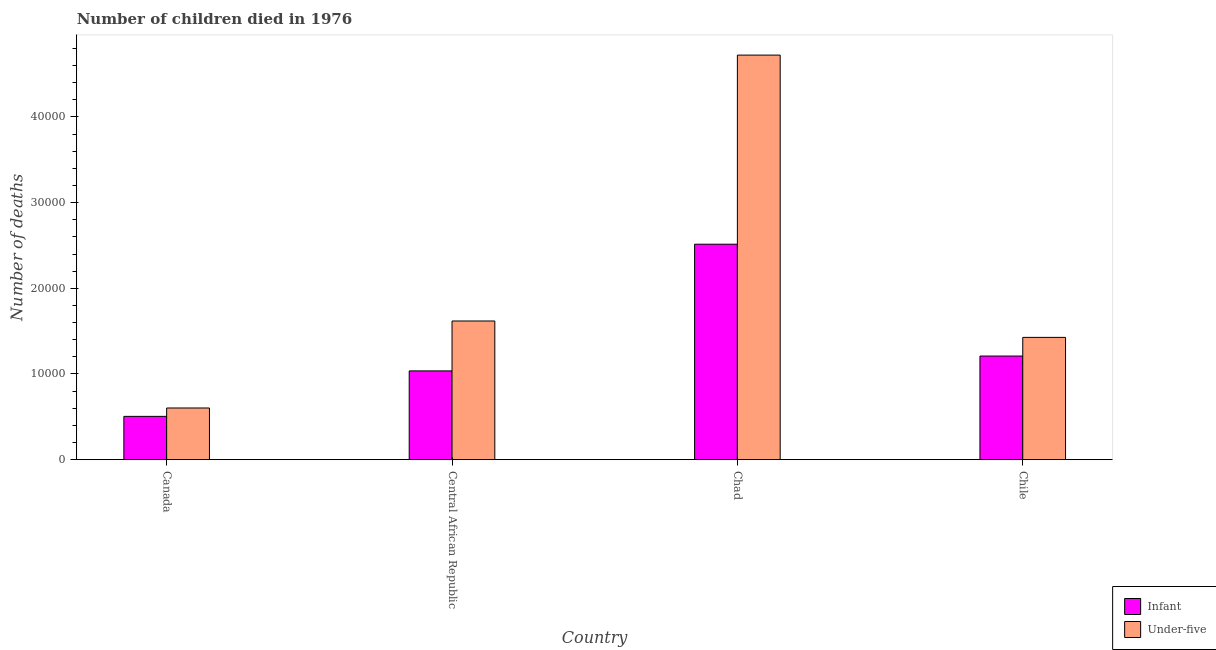How many bars are there on the 1st tick from the left?
Your answer should be compact. 2. How many bars are there on the 4th tick from the right?
Provide a short and direct response. 2. What is the label of the 2nd group of bars from the left?
Ensure brevity in your answer.  Central African Republic. What is the number of infant deaths in Chad?
Provide a succinct answer. 2.51e+04. Across all countries, what is the maximum number of infant deaths?
Offer a very short reply. 2.51e+04. Across all countries, what is the minimum number of under-five deaths?
Give a very brief answer. 6034. In which country was the number of under-five deaths maximum?
Offer a very short reply. Chad. In which country was the number of infant deaths minimum?
Offer a very short reply. Canada. What is the total number of infant deaths in the graph?
Offer a terse response. 5.27e+04. What is the difference between the number of infant deaths in Chad and that in Chile?
Ensure brevity in your answer.  1.30e+04. What is the difference between the number of under-five deaths in Chad and the number of infant deaths in Central African Republic?
Your answer should be very brief. 3.68e+04. What is the average number of infant deaths per country?
Offer a very short reply. 1.32e+04. What is the difference between the number of infant deaths and number of under-five deaths in Chad?
Offer a very short reply. -2.21e+04. In how many countries, is the number of under-five deaths greater than 38000 ?
Provide a short and direct response. 1. What is the ratio of the number of under-five deaths in Canada to that in Central African Republic?
Offer a very short reply. 0.37. What is the difference between the highest and the second highest number of infant deaths?
Make the answer very short. 1.30e+04. What is the difference between the highest and the lowest number of under-five deaths?
Your answer should be very brief. 4.12e+04. In how many countries, is the number of under-five deaths greater than the average number of under-five deaths taken over all countries?
Your answer should be compact. 1. What does the 2nd bar from the left in Central African Republic represents?
Offer a very short reply. Under-five. What does the 2nd bar from the right in Chile represents?
Ensure brevity in your answer.  Infant. Where does the legend appear in the graph?
Provide a succinct answer. Bottom right. How many legend labels are there?
Your answer should be very brief. 2. How are the legend labels stacked?
Make the answer very short. Vertical. What is the title of the graph?
Your response must be concise. Number of children died in 1976. What is the label or title of the Y-axis?
Your answer should be very brief. Number of deaths. What is the Number of deaths of Infant in Canada?
Keep it short and to the point. 5057. What is the Number of deaths of Under-five in Canada?
Offer a terse response. 6034. What is the Number of deaths of Infant in Central African Republic?
Keep it short and to the point. 1.04e+04. What is the Number of deaths of Under-five in Central African Republic?
Make the answer very short. 1.62e+04. What is the Number of deaths in Infant in Chad?
Give a very brief answer. 2.51e+04. What is the Number of deaths of Under-five in Chad?
Provide a short and direct response. 4.72e+04. What is the Number of deaths of Infant in Chile?
Provide a succinct answer. 1.21e+04. What is the Number of deaths of Under-five in Chile?
Your response must be concise. 1.43e+04. Across all countries, what is the maximum Number of deaths in Infant?
Make the answer very short. 2.51e+04. Across all countries, what is the maximum Number of deaths in Under-five?
Offer a very short reply. 4.72e+04. Across all countries, what is the minimum Number of deaths in Infant?
Offer a very short reply. 5057. Across all countries, what is the minimum Number of deaths in Under-five?
Give a very brief answer. 6034. What is the total Number of deaths of Infant in the graph?
Your response must be concise. 5.27e+04. What is the total Number of deaths of Under-five in the graph?
Your answer should be very brief. 8.37e+04. What is the difference between the Number of deaths of Infant in Canada and that in Central African Republic?
Offer a terse response. -5304. What is the difference between the Number of deaths in Under-five in Canada and that in Central African Republic?
Your response must be concise. -1.02e+04. What is the difference between the Number of deaths of Infant in Canada and that in Chad?
Make the answer very short. -2.01e+04. What is the difference between the Number of deaths of Under-five in Canada and that in Chad?
Your answer should be compact. -4.12e+04. What is the difference between the Number of deaths of Infant in Canada and that in Chile?
Your response must be concise. -7039. What is the difference between the Number of deaths in Under-five in Canada and that in Chile?
Your answer should be compact. -8238. What is the difference between the Number of deaths of Infant in Central African Republic and that in Chad?
Provide a succinct answer. -1.48e+04. What is the difference between the Number of deaths of Under-five in Central African Republic and that in Chad?
Give a very brief answer. -3.10e+04. What is the difference between the Number of deaths of Infant in Central African Republic and that in Chile?
Offer a terse response. -1735. What is the difference between the Number of deaths in Under-five in Central African Republic and that in Chile?
Offer a terse response. 1914. What is the difference between the Number of deaths in Infant in Chad and that in Chile?
Make the answer very short. 1.30e+04. What is the difference between the Number of deaths of Under-five in Chad and that in Chile?
Your answer should be very brief. 3.29e+04. What is the difference between the Number of deaths of Infant in Canada and the Number of deaths of Under-five in Central African Republic?
Your answer should be compact. -1.11e+04. What is the difference between the Number of deaths of Infant in Canada and the Number of deaths of Under-five in Chad?
Provide a short and direct response. -4.22e+04. What is the difference between the Number of deaths in Infant in Canada and the Number of deaths in Under-five in Chile?
Offer a very short reply. -9215. What is the difference between the Number of deaths of Infant in Central African Republic and the Number of deaths of Under-five in Chad?
Keep it short and to the point. -3.68e+04. What is the difference between the Number of deaths of Infant in Central African Republic and the Number of deaths of Under-five in Chile?
Your response must be concise. -3911. What is the difference between the Number of deaths in Infant in Chad and the Number of deaths in Under-five in Chile?
Make the answer very short. 1.09e+04. What is the average Number of deaths in Infant per country?
Keep it short and to the point. 1.32e+04. What is the average Number of deaths in Under-five per country?
Keep it short and to the point. 2.09e+04. What is the difference between the Number of deaths in Infant and Number of deaths in Under-five in Canada?
Your answer should be very brief. -977. What is the difference between the Number of deaths of Infant and Number of deaths of Under-five in Central African Republic?
Ensure brevity in your answer.  -5825. What is the difference between the Number of deaths of Infant and Number of deaths of Under-five in Chad?
Offer a terse response. -2.21e+04. What is the difference between the Number of deaths of Infant and Number of deaths of Under-five in Chile?
Ensure brevity in your answer.  -2176. What is the ratio of the Number of deaths in Infant in Canada to that in Central African Republic?
Offer a very short reply. 0.49. What is the ratio of the Number of deaths in Under-five in Canada to that in Central African Republic?
Offer a terse response. 0.37. What is the ratio of the Number of deaths of Infant in Canada to that in Chad?
Offer a very short reply. 0.2. What is the ratio of the Number of deaths in Under-five in Canada to that in Chad?
Your response must be concise. 0.13. What is the ratio of the Number of deaths in Infant in Canada to that in Chile?
Your response must be concise. 0.42. What is the ratio of the Number of deaths of Under-five in Canada to that in Chile?
Give a very brief answer. 0.42. What is the ratio of the Number of deaths in Infant in Central African Republic to that in Chad?
Your answer should be compact. 0.41. What is the ratio of the Number of deaths in Under-five in Central African Republic to that in Chad?
Make the answer very short. 0.34. What is the ratio of the Number of deaths of Infant in Central African Republic to that in Chile?
Offer a terse response. 0.86. What is the ratio of the Number of deaths of Under-five in Central African Republic to that in Chile?
Make the answer very short. 1.13. What is the ratio of the Number of deaths in Infant in Chad to that in Chile?
Keep it short and to the point. 2.08. What is the ratio of the Number of deaths of Under-five in Chad to that in Chile?
Keep it short and to the point. 3.31. What is the difference between the highest and the second highest Number of deaths of Infant?
Offer a very short reply. 1.30e+04. What is the difference between the highest and the second highest Number of deaths in Under-five?
Your answer should be compact. 3.10e+04. What is the difference between the highest and the lowest Number of deaths of Infant?
Make the answer very short. 2.01e+04. What is the difference between the highest and the lowest Number of deaths in Under-five?
Make the answer very short. 4.12e+04. 